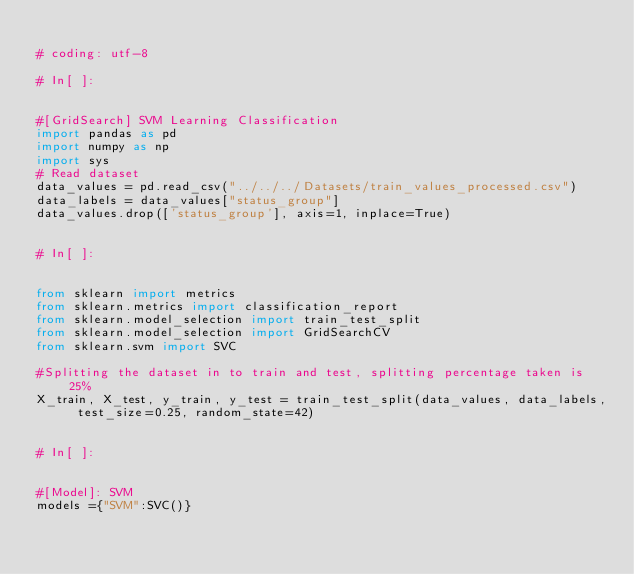Convert code to text. <code><loc_0><loc_0><loc_500><loc_500><_Python_>
# coding: utf-8

# In[ ]:


#[GridSearch] SVM Learning Classification
import pandas as pd
import numpy as np
import sys
# Read dataset
data_values = pd.read_csv("../../../Datasets/train_values_processed.csv")
data_labels = data_values["status_group"]
data_values.drop(['status_group'], axis=1, inplace=True)


# In[ ]:


from sklearn import metrics
from sklearn.metrics import classification_report
from sklearn.model_selection import train_test_split
from sklearn.model_selection import GridSearchCV
from sklearn.svm import SVC

#Splitting the dataset in to train and test, splitting percentage taken is 25%
X_train, X_test, y_train, y_test = train_test_split(data_values, data_labels, test_size=0.25, random_state=42)


# In[ ]:


#[Model]: SVM 
models ={"SVM":SVC()}</code> 